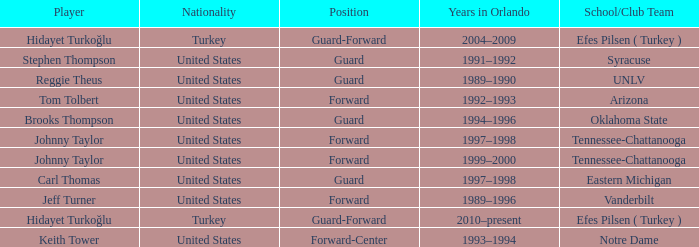What is Stephen Thompson's School/Club Team? Syracuse. 